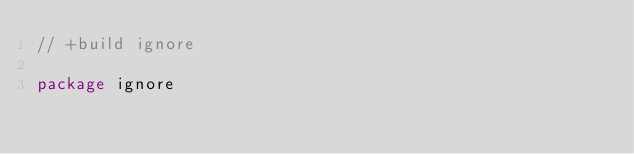Convert code to text. <code><loc_0><loc_0><loc_500><loc_500><_Go_>// +build ignore

package ignore
</code> 